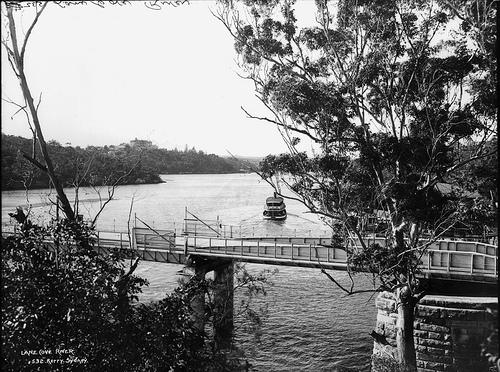Are there any people on the bridge?
Concise answer only. No. What kind of boats are these?
Be succinct. Riverboat. Is there a reflection on the water?
Write a very short answer. No. Could large semi trucks cross this bridge?
Be succinct. No. What is the bridge going over?
Concise answer only. Water. 